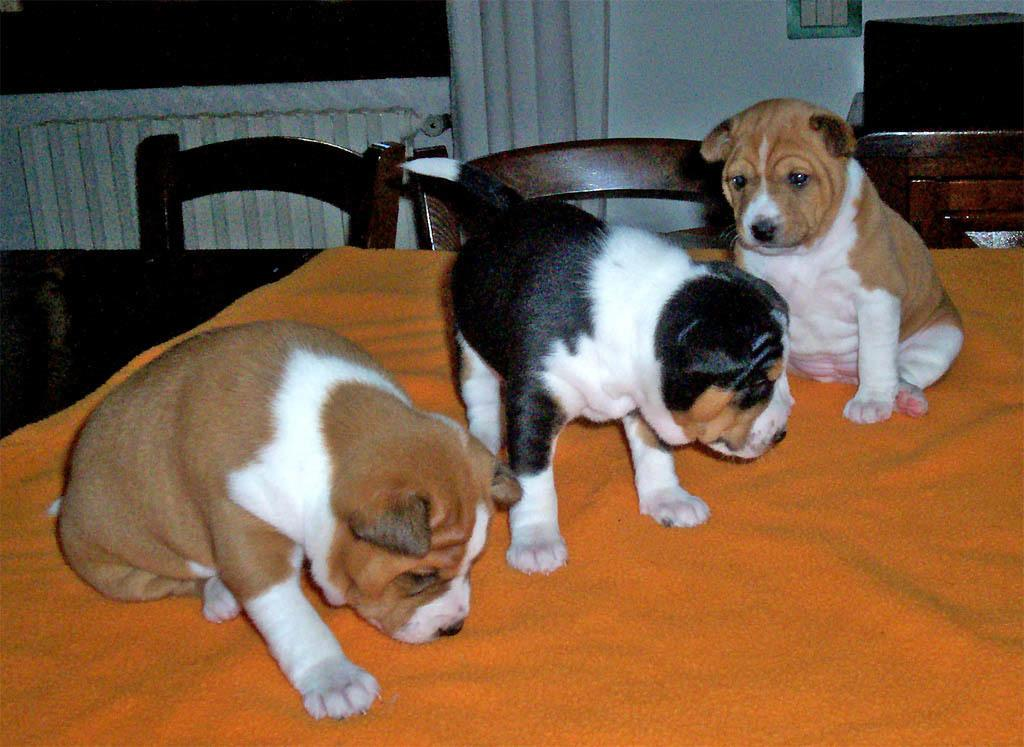What animals are on the cloth in the image? There are dogs on a cloth in the image. What type of furniture is present in the image? There are chairs in the image. What type of juice is being served in the crown in the image? There is no juice or crown present in the image. The focus is on the dogs on the cloth and the chairs. 